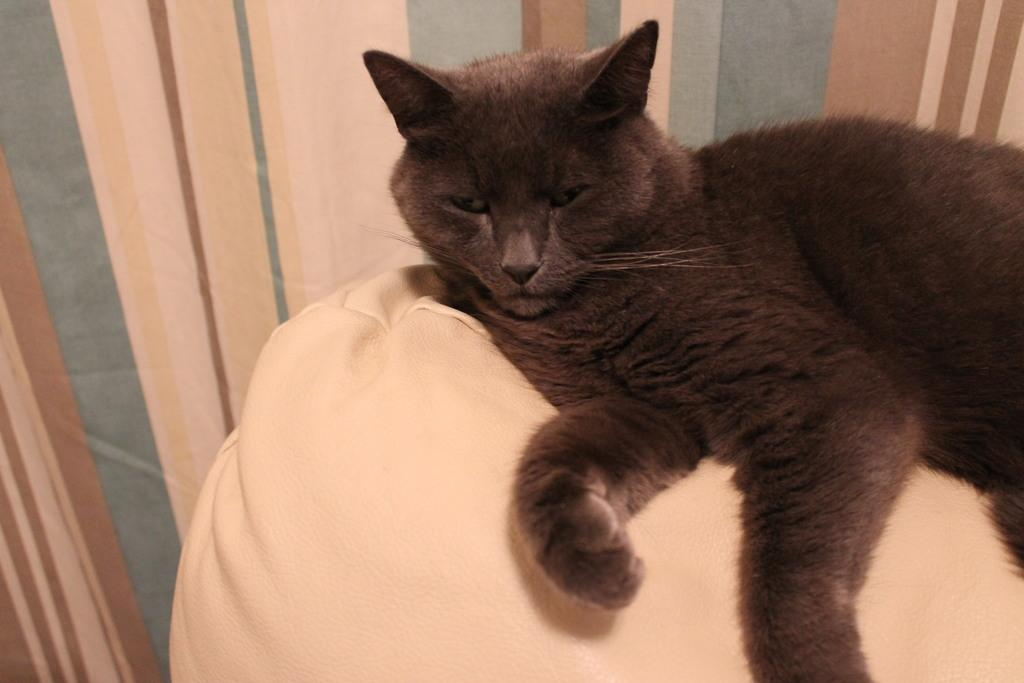What animal can be seen in the picture? There is a cat in the picture. What is the cat doing in the image? The cat is sleeping on a pillow. What color is the cat in the image? The cat is black in color. What type of window treatment is visible in the image? There is a curtain visible in the image. What is the cat's tendency to jump on beds in the image? There is no information about the cat's tendency to jump on beds in the image. --- Facts: 1. There is a car in the image. 2. The car is parked on the street. 3. The car is red in color. 4. There is a traffic light visible in the image. Absurd Topics: dance, ocean, monkey Conversation: What vehicle is in the image? There is a car in the image. Where is the car located in the image? The car is parked on the street. What color is the car in the image? The car is red in color. What type of traffic control device is visible in the image? There is a traffic light visible in the image. Reasoning: Let's think step by step in order to produce the conversation. We start by identifying the main subject in the image, which is the car. Then, we describe the car's location and color. Finally, we mention the traffic light as an additional detail in the image. Each question is designed to elicit a specific detail about the image that is known from the provided facts. Absurd Question/Answer: Can you see any monkeys dancing in the ocean in the image? There are no monkeys or ocean present in the image. 